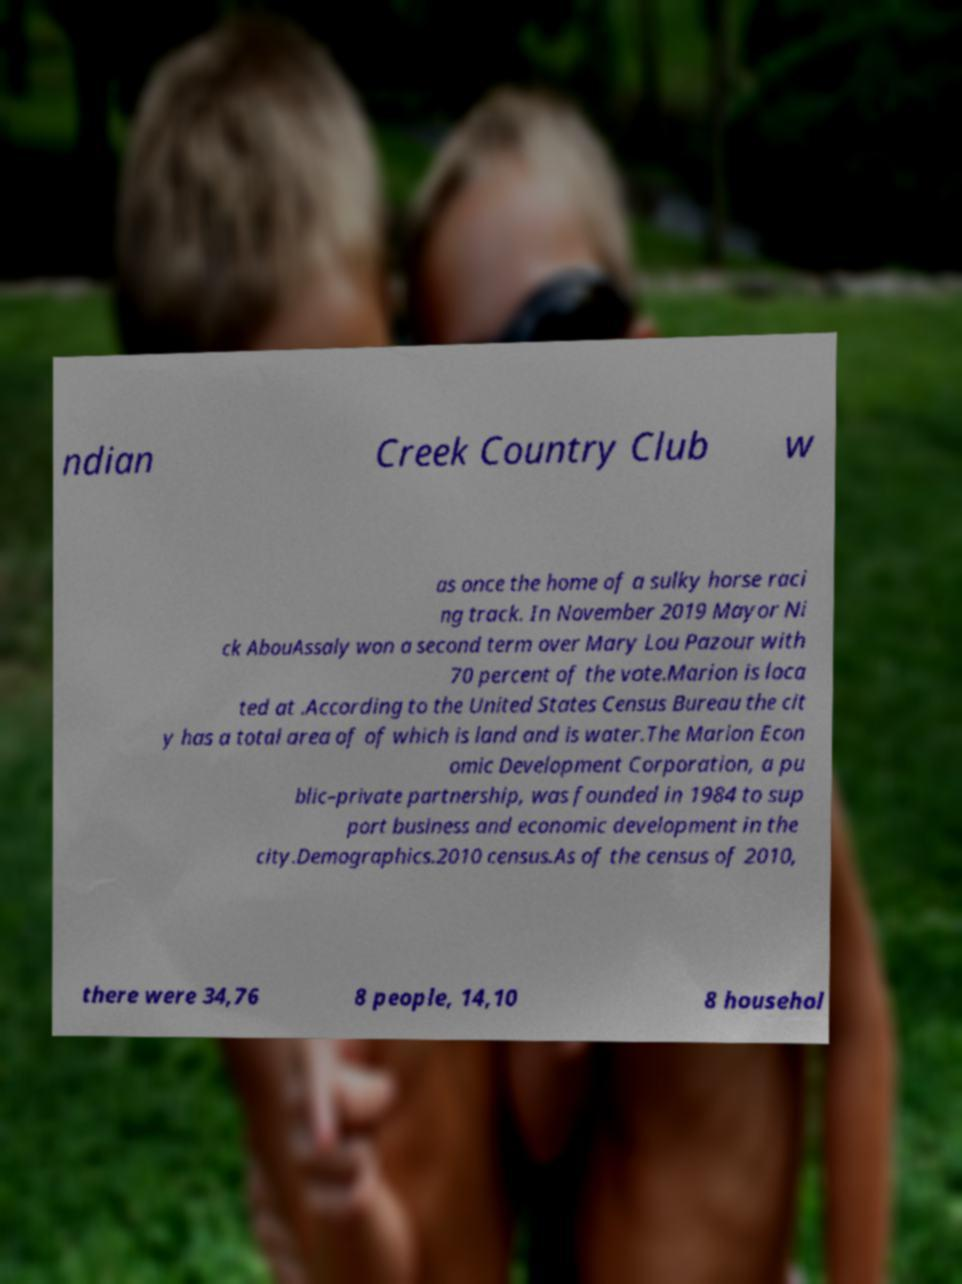Could you assist in decoding the text presented in this image and type it out clearly? ndian Creek Country Club w as once the home of a sulky horse raci ng track. In November 2019 Mayor Ni ck AbouAssaly won a second term over Mary Lou Pazour with 70 percent of the vote.Marion is loca ted at .According to the United States Census Bureau the cit y has a total area of of which is land and is water.The Marion Econ omic Development Corporation, a pu blic–private partnership, was founded in 1984 to sup port business and economic development in the city.Demographics.2010 census.As of the census of 2010, there were 34,76 8 people, 14,10 8 househol 